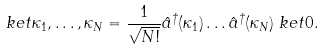<formula> <loc_0><loc_0><loc_500><loc_500>\ k e t { \kappa _ { 1 } , \dots , \kappa _ { N } } & = \frac { 1 } { \sqrt { N ! } } \hat { a } ^ { \dagger } ( \kappa _ { 1 } ) \dots \hat { a } ^ { \dagger } ( \kappa _ { N } ) \ k e t { 0 } .</formula> 